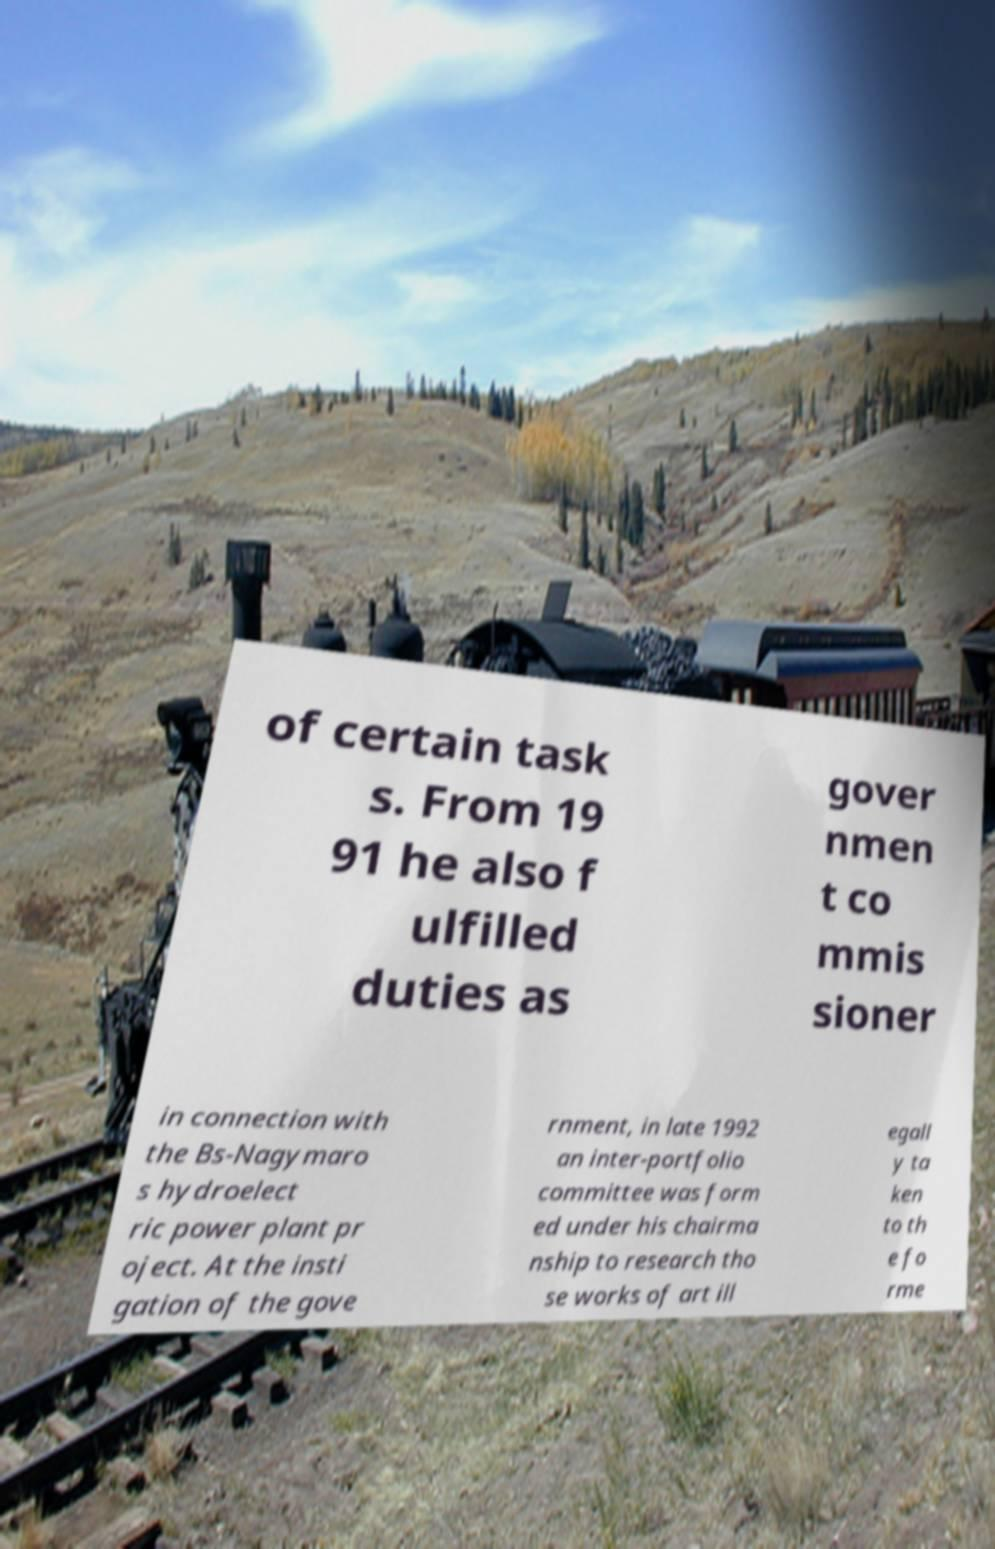Can you accurately transcribe the text from the provided image for me? of certain task s. From 19 91 he also f ulfilled duties as gover nmen t co mmis sioner in connection with the Bs-Nagymaro s hydroelect ric power plant pr oject. At the insti gation of the gove rnment, in late 1992 an inter-portfolio committee was form ed under his chairma nship to research tho se works of art ill egall y ta ken to th e fo rme 